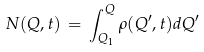Convert formula to latex. <formula><loc_0><loc_0><loc_500><loc_500>N ( Q , t ) \, = \, \int _ { Q _ { 1 } } ^ { Q } \rho ( Q ^ { \prime } , t ) d Q ^ { \prime }</formula> 